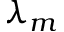Convert formula to latex. <formula><loc_0><loc_0><loc_500><loc_500>\lambda _ { m }</formula> 